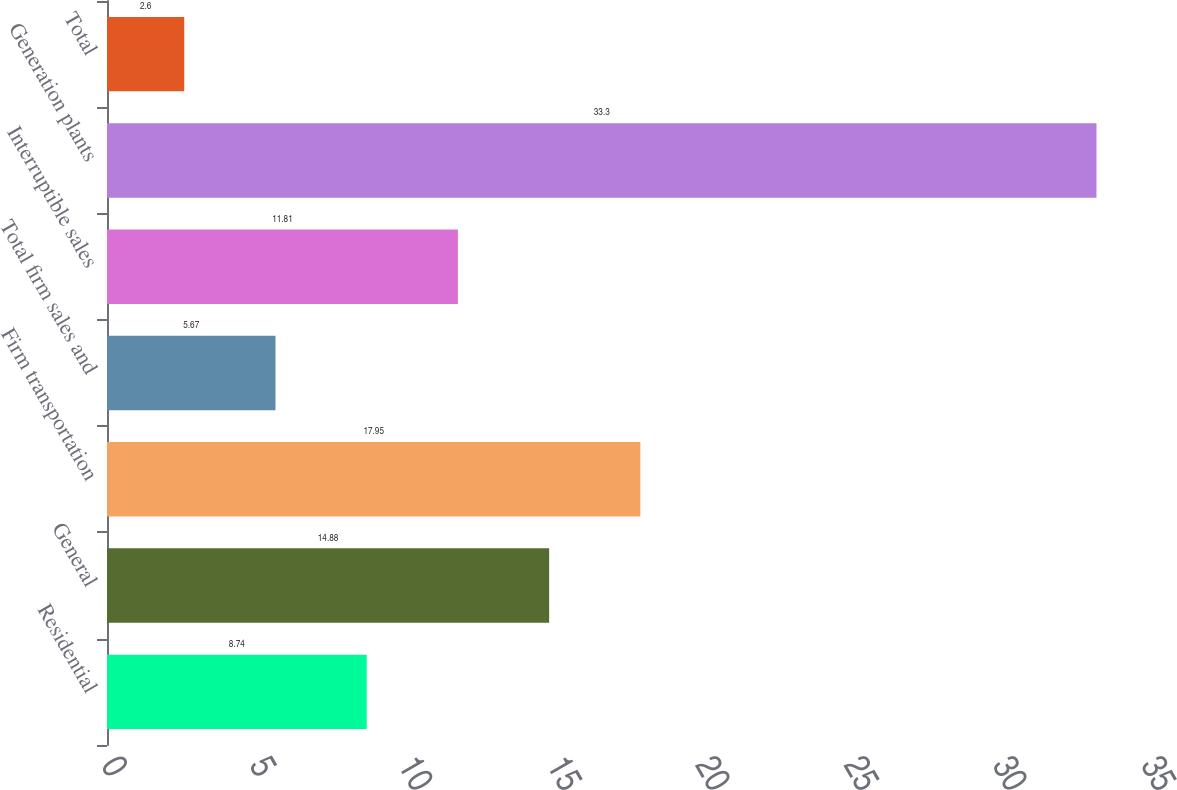Convert chart to OTSL. <chart><loc_0><loc_0><loc_500><loc_500><bar_chart><fcel>Residential<fcel>General<fcel>Firm transportation<fcel>Total firm sales and<fcel>Interruptible sales<fcel>Generation plants<fcel>Total<nl><fcel>8.74<fcel>14.88<fcel>17.95<fcel>5.67<fcel>11.81<fcel>33.3<fcel>2.6<nl></chart> 